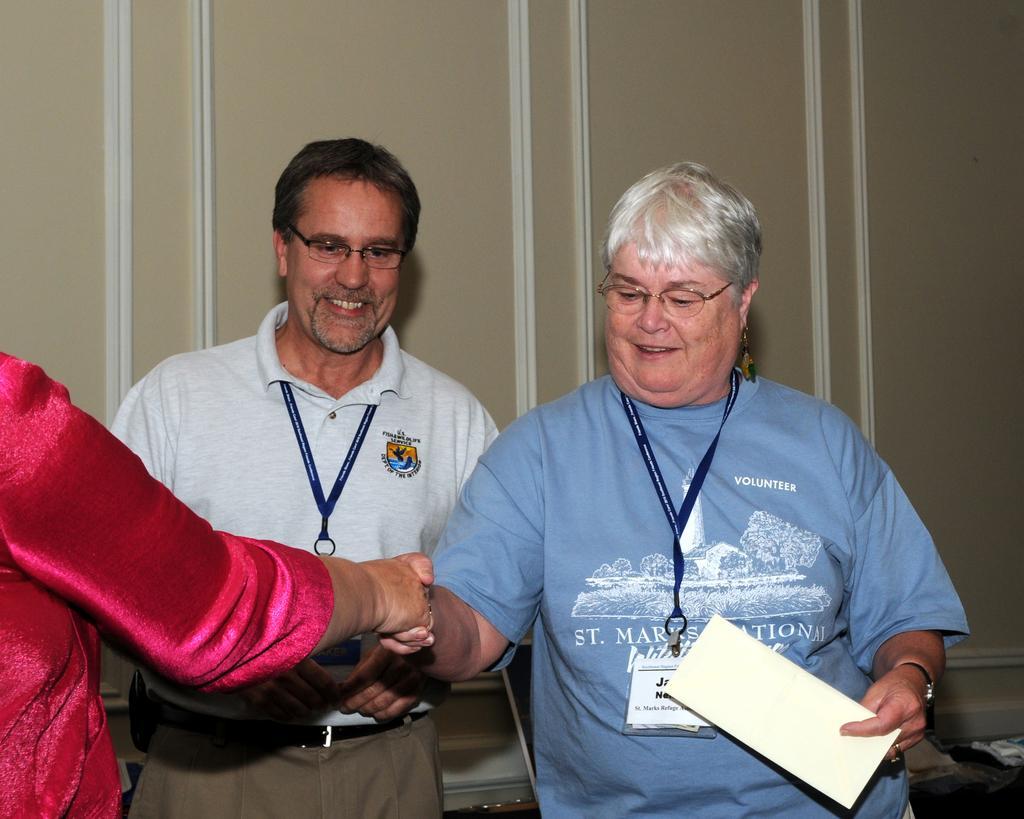How would you summarize this image in a sentence or two? In the center of the image we can see two persons with glasses and are smiling and standing and there is also another person on the left. In the background we can see the wall. 